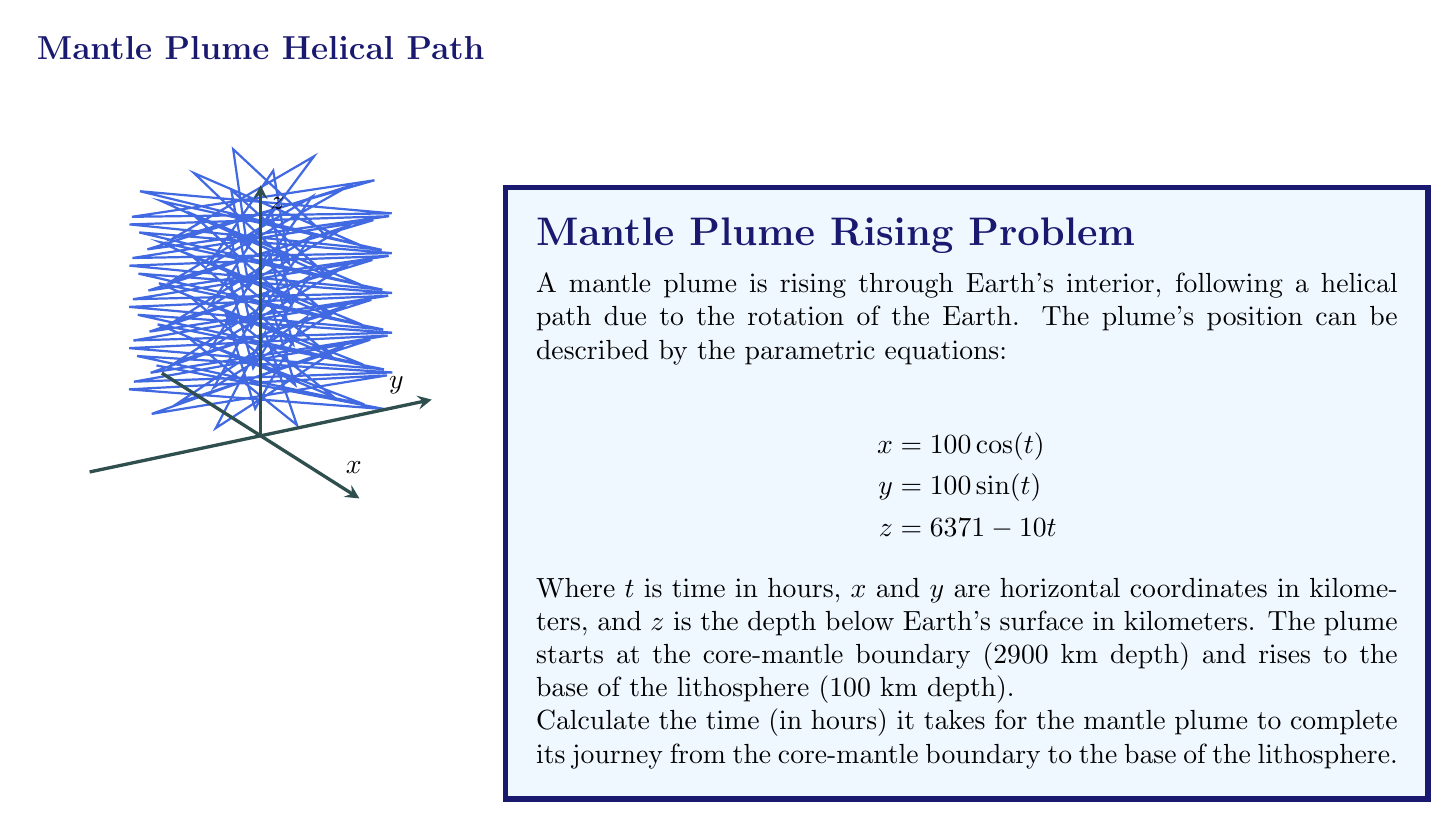Can you solve this math problem? Let's approach this step-by-step:

1) We need to find the time $t$ when the plume reaches the base of the lithosphere. This occurs when $z = 6371 - 100$ (since the lithosphere base is 100 km deep).

2) We can set up the equation:
   $$6371 - 100 = 6371 - 10t$$

3) Simplify:
   $$6271 = 6371 - 10t$$

4) Subtract 6371 from both sides:
   $$-100 = -10t$$

5) Divide both sides by -10:
   $$10 = t$$

6) Therefore, it takes 10 hours for the plume to rise from the core-mantle boundary to the base of the lithosphere.

7) To verify, we can check the starting and ending points:

   At $t = 0$ (start):
   $$z = 6371 - 10(0) = 6371$$ km from the center, or 2900 km deep (core-mantle boundary)

   At $t = 10$ (end):
   $$z = 6371 - 10(10) = 6271$$ km from the center, or 100 km deep (base of lithosphere)

This confirms our calculation is correct.
Answer: 10 hours 